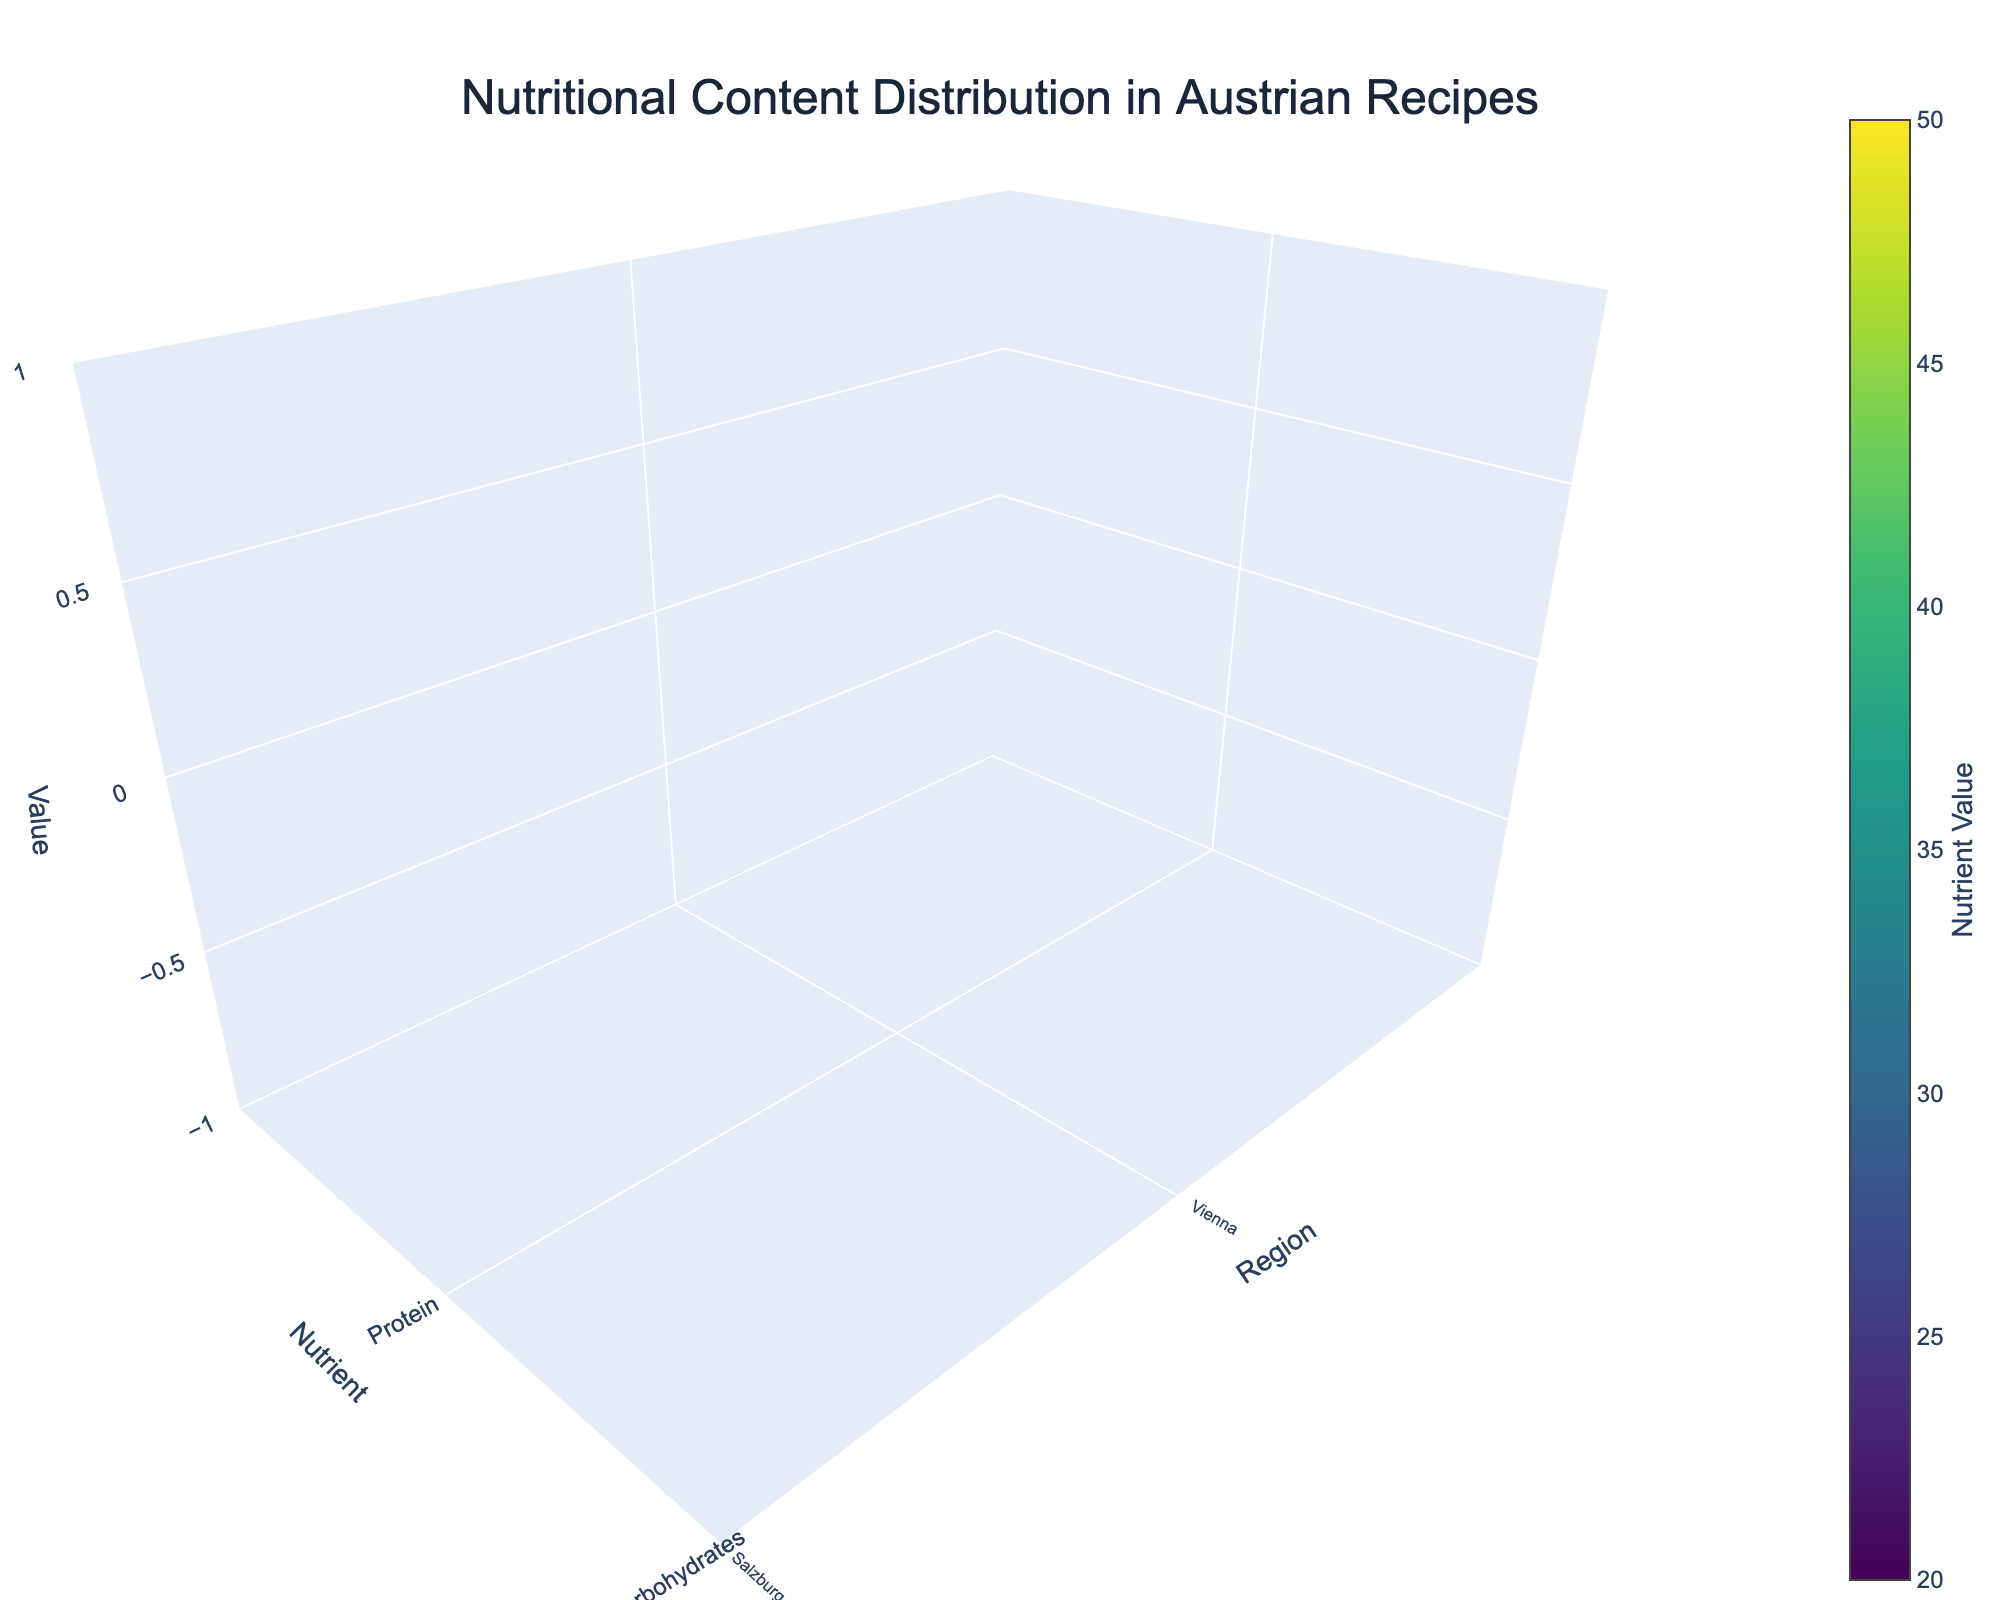What is the main title of the plot? The main title of the plot is displayed at the top and gives an overview of the content. It reads "Nutritional Content Distribution in Austrian Recipes".
Answer: Nutritional Content Distribution in Austrian Recipes Which region has the highest carbohydrate content? To find the region with the highest carbohydrate content, locate the tallest points related to carbohydrates. Styria has the highest carbohydrate value at 48.
Answer: Styria How does the protein content in Tyrol compare to that in Carinthia? By comparing the bars representing protein in Tyrol and Carinthia, we observe that Tyrol has a protein content of 30, while Carinthia has 24. Thus, Tyrol has a higher protein content.
Answer: Tyrol has a higher protein content What's the nutrient with the highest overall value in the plot? To determine the nutrient with the highest value, look for the tallest bars across all regions. Carbohydrates in Styria peak at 48, which is the highest value in the plot.
Answer: Carbohydrates Which region has the lowest fat content? To find the region with the lowest fat content, look for the shortest bars in the fat category. Salzburg has the lowest fat content value at 27.
Answer: Salzburg What is the average protein content across all regions? Summing the protein values (25+28+30+22+26+24+23+27+25) gives 230. Dividing by the number of regions (9) results in an average protein content of approximately 25.56.
Answer: 25.56 Which nutrient shows the greatest variation in content values across regions? To determine which nutrient shows the greatest variation, compare the range of values for each nutrient. Carbohydrates vary from 35 to 48, showing the greatest spread in values.
Answer: Carbohydrates How does Vienna's fat content compare to Lower Austria's fat content? By comparing the corresponding bars, we see Vienna's fat content is 35, while Lower Austria's is 32. Therefore, Vienna has a higher fat content.
Answer: Vienna has a higher fat content What is the combined carbohydrate content of Salzburg and Vorarlberg? The carbohydrate content of Salzburg is 45 and Vorarlberg is 36. Summing these values gives a total of 81.
Answer: 81 